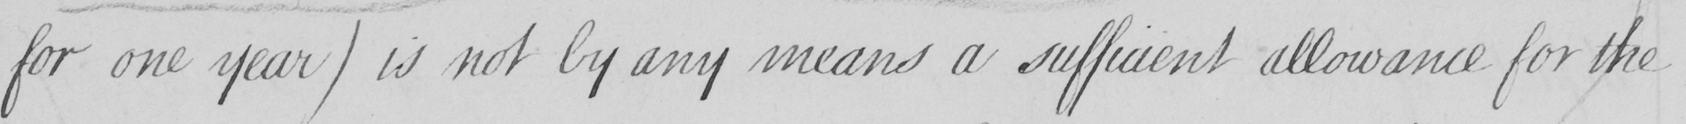What text is written in this handwritten line? for one year )  is not by any means a sufficient allowance for the 